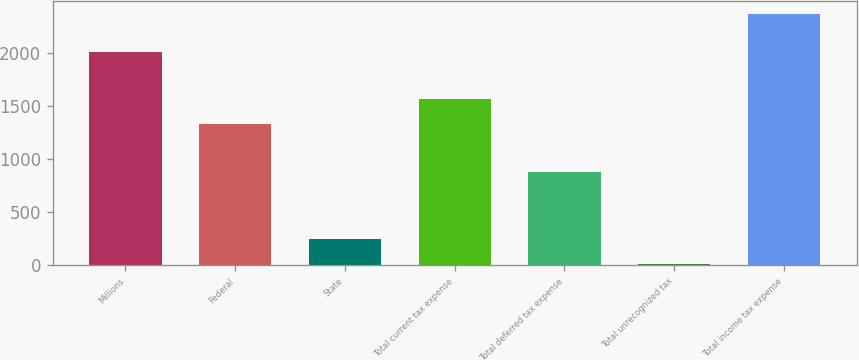Convert chart to OTSL. <chart><loc_0><loc_0><loc_500><loc_500><bar_chart><fcel>Millions<fcel>Federal<fcel>State<fcel>Total current tax expense<fcel>Total deferred tax expense<fcel>Total unrecognized tax<fcel>Total income tax expense<nl><fcel>2012<fcel>1335<fcel>243.8<fcel>1571.8<fcel>880<fcel>7<fcel>2375<nl></chart> 